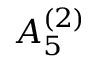<formula> <loc_0><loc_0><loc_500><loc_500>{ A } _ { 5 } ^ { ( 2 ) }</formula> 